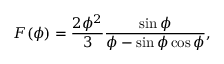Convert formula to latex. <formula><loc_0><loc_0><loc_500><loc_500>F ( \phi ) = \frac { 2 \phi ^ { 2 } } { 3 } \frac { \sin { \phi } } { \phi - \sin \phi \cos \phi } ,</formula> 